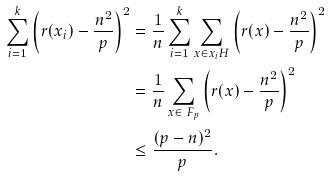Convert formula to latex. <formula><loc_0><loc_0><loc_500><loc_500>\sum _ { i = 1 } ^ { k } \left ( r ( x _ { i } ) - \frac { n ^ { 2 } } { p } \right ) ^ { 2 } & = \frac { 1 } { n } \sum _ { i = 1 } ^ { k } \sum _ { x \in x _ { i } H } \left ( r ( x ) - \frac { n ^ { 2 } } { p } \right ) ^ { 2 } \\ & = \frac { 1 } { n } \sum _ { x \in \ F _ { p } } \left ( r ( x ) - \frac { n ^ { 2 } } { p } \right ) ^ { 2 } \\ & \leq \frac { ( p - n ) ^ { 2 } } { p } .</formula> 